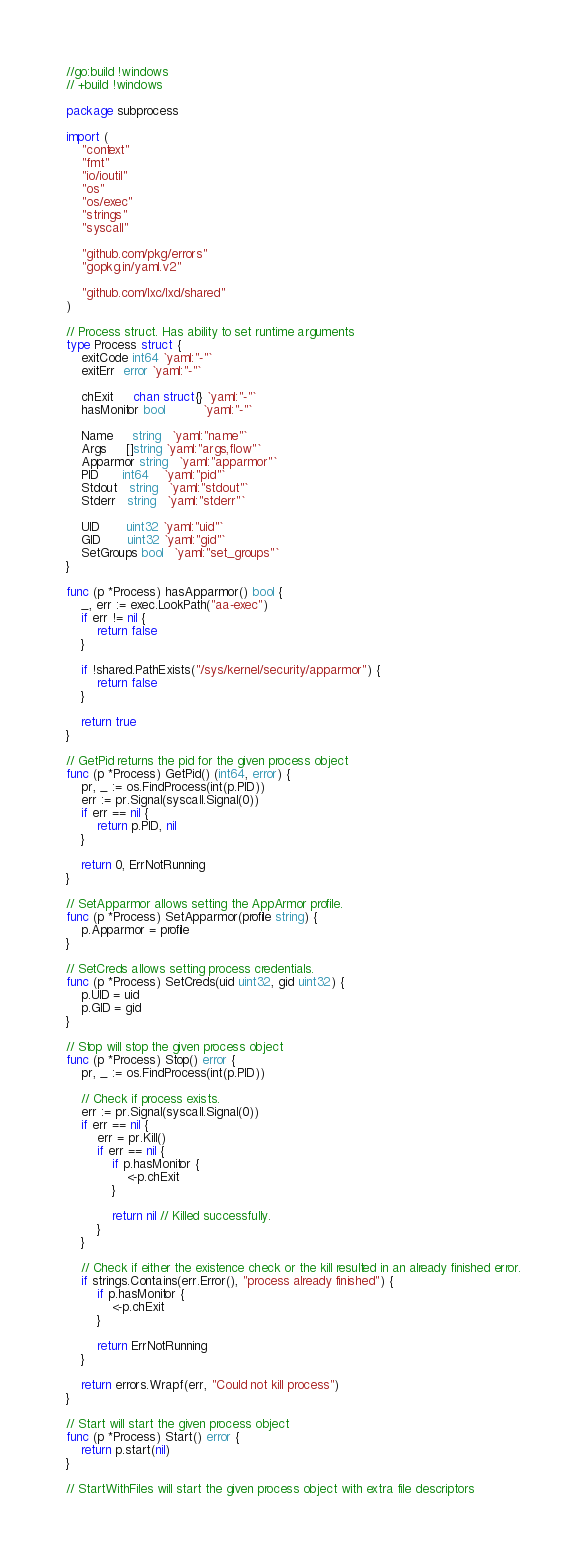Convert code to text. <code><loc_0><loc_0><loc_500><loc_500><_Go_>//go:build !windows
// +build !windows

package subprocess

import (
	"context"
	"fmt"
	"io/ioutil"
	"os"
	"os/exec"
	"strings"
	"syscall"

	"github.com/pkg/errors"
	"gopkg.in/yaml.v2"

	"github.com/lxc/lxd/shared"
)

// Process struct. Has ability to set runtime arguments
type Process struct {
	exitCode int64 `yaml:"-"`
	exitErr  error `yaml:"-"`

	chExit     chan struct{} `yaml:"-"`
	hasMonitor bool          `yaml:"-"`

	Name     string   `yaml:"name"`
	Args     []string `yaml:"args,flow"`
	Apparmor string   `yaml:"apparmor"`
	PID      int64    `yaml:"pid"`
	Stdout   string   `yaml:"stdout"`
	Stderr   string   `yaml:"stderr"`

	UID       uint32 `yaml:"uid"`
	GID       uint32 `yaml:"gid"`
	SetGroups bool   `yaml:"set_groups"`
}

func (p *Process) hasApparmor() bool {
	_, err := exec.LookPath("aa-exec")
	if err != nil {
		return false
	}

	if !shared.PathExists("/sys/kernel/security/apparmor") {
		return false
	}

	return true
}

// GetPid returns the pid for the given process object
func (p *Process) GetPid() (int64, error) {
	pr, _ := os.FindProcess(int(p.PID))
	err := pr.Signal(syscall.Signal(0))
	if err == nil {
		return p.PID, nil
	}

	return 0, ErrNotRunning
}

// SetApparmor allows setting the AppArmor profile.
func (p *Process) SetApparmor(profile string) {
	p.Apparmor = profile
}

// SetCreds allows setting process credentials.
func (p *Process) SetCreds(uid uint32, gid uint32) {
	p.UID = uid
	p.GID = gid
}

// Stop will stop the given process object
func (p *Process) Stop() error {
	pr, _ := os.FindProcess(int(p.PID))

	// Check if process exists.
	err := pr.Signal(syscall.Signal(0))
	if err == nil {
		err = pr.Kill()
		if err == nil {
			if p.hasMonitor {
				<-p.chExit
			}

			return nil // Killed successfully.
		}
	}

	// Check if either the existence check or the kill resulted in an already finished error.
	if strings.Contains(err.Error(), "process already finished") {
		if p.hasMonitor {
			<-p.chExit
		}

		return ErrNotRunning
	}

	return errors.Wrapf(err, "Could not kill process")
}

// Start will start the given process object
func (p *Process) Start() error {
	return p.start(nil)
}

// StartWithFiles will start the given process object with extra file descriptors</code> 